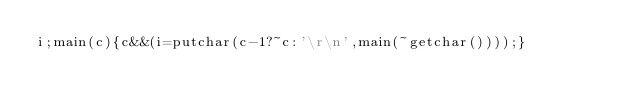<code> <loc_0><loc_0><loc_500><loc_500><_C_>i;main(c){c&&(i=putchar(c-1?~c:'\r\n',main(~getchar())));}</code> 